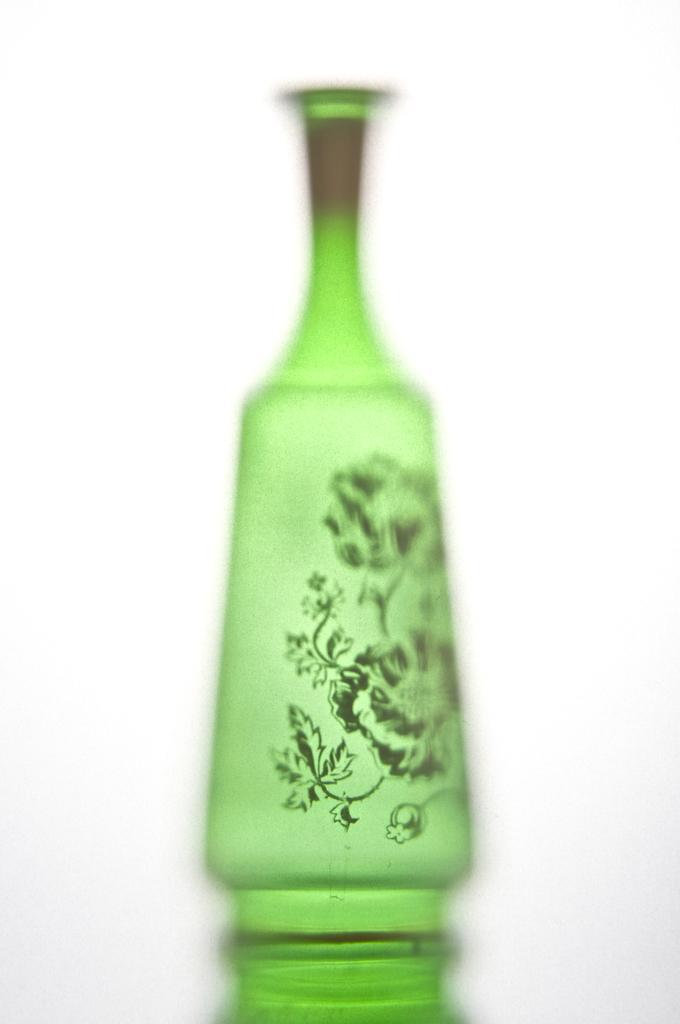Can you describe this image briefly? This picture is consists of a flower pot which is green in color and the background of the image is white. 